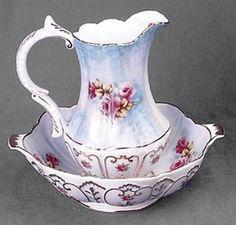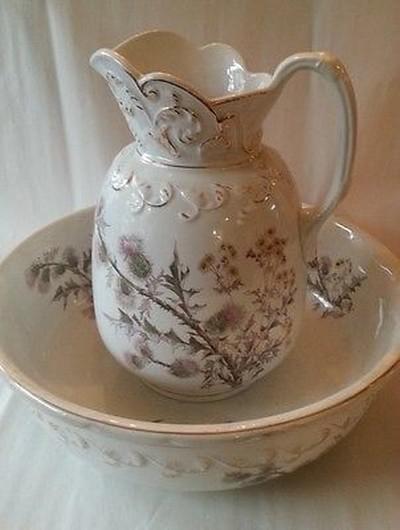The first image is the image on the left, the second image is the image on the right. Considering the images on both sides, is "The spout of every pitcher is facing to the left." valid? Answer yes or no. No. The first image is the image on the left, the second image is the image on the right. For the images displayed, is the sentence "Both handles are on the right side." factually correct? Answer yes or no. No. 